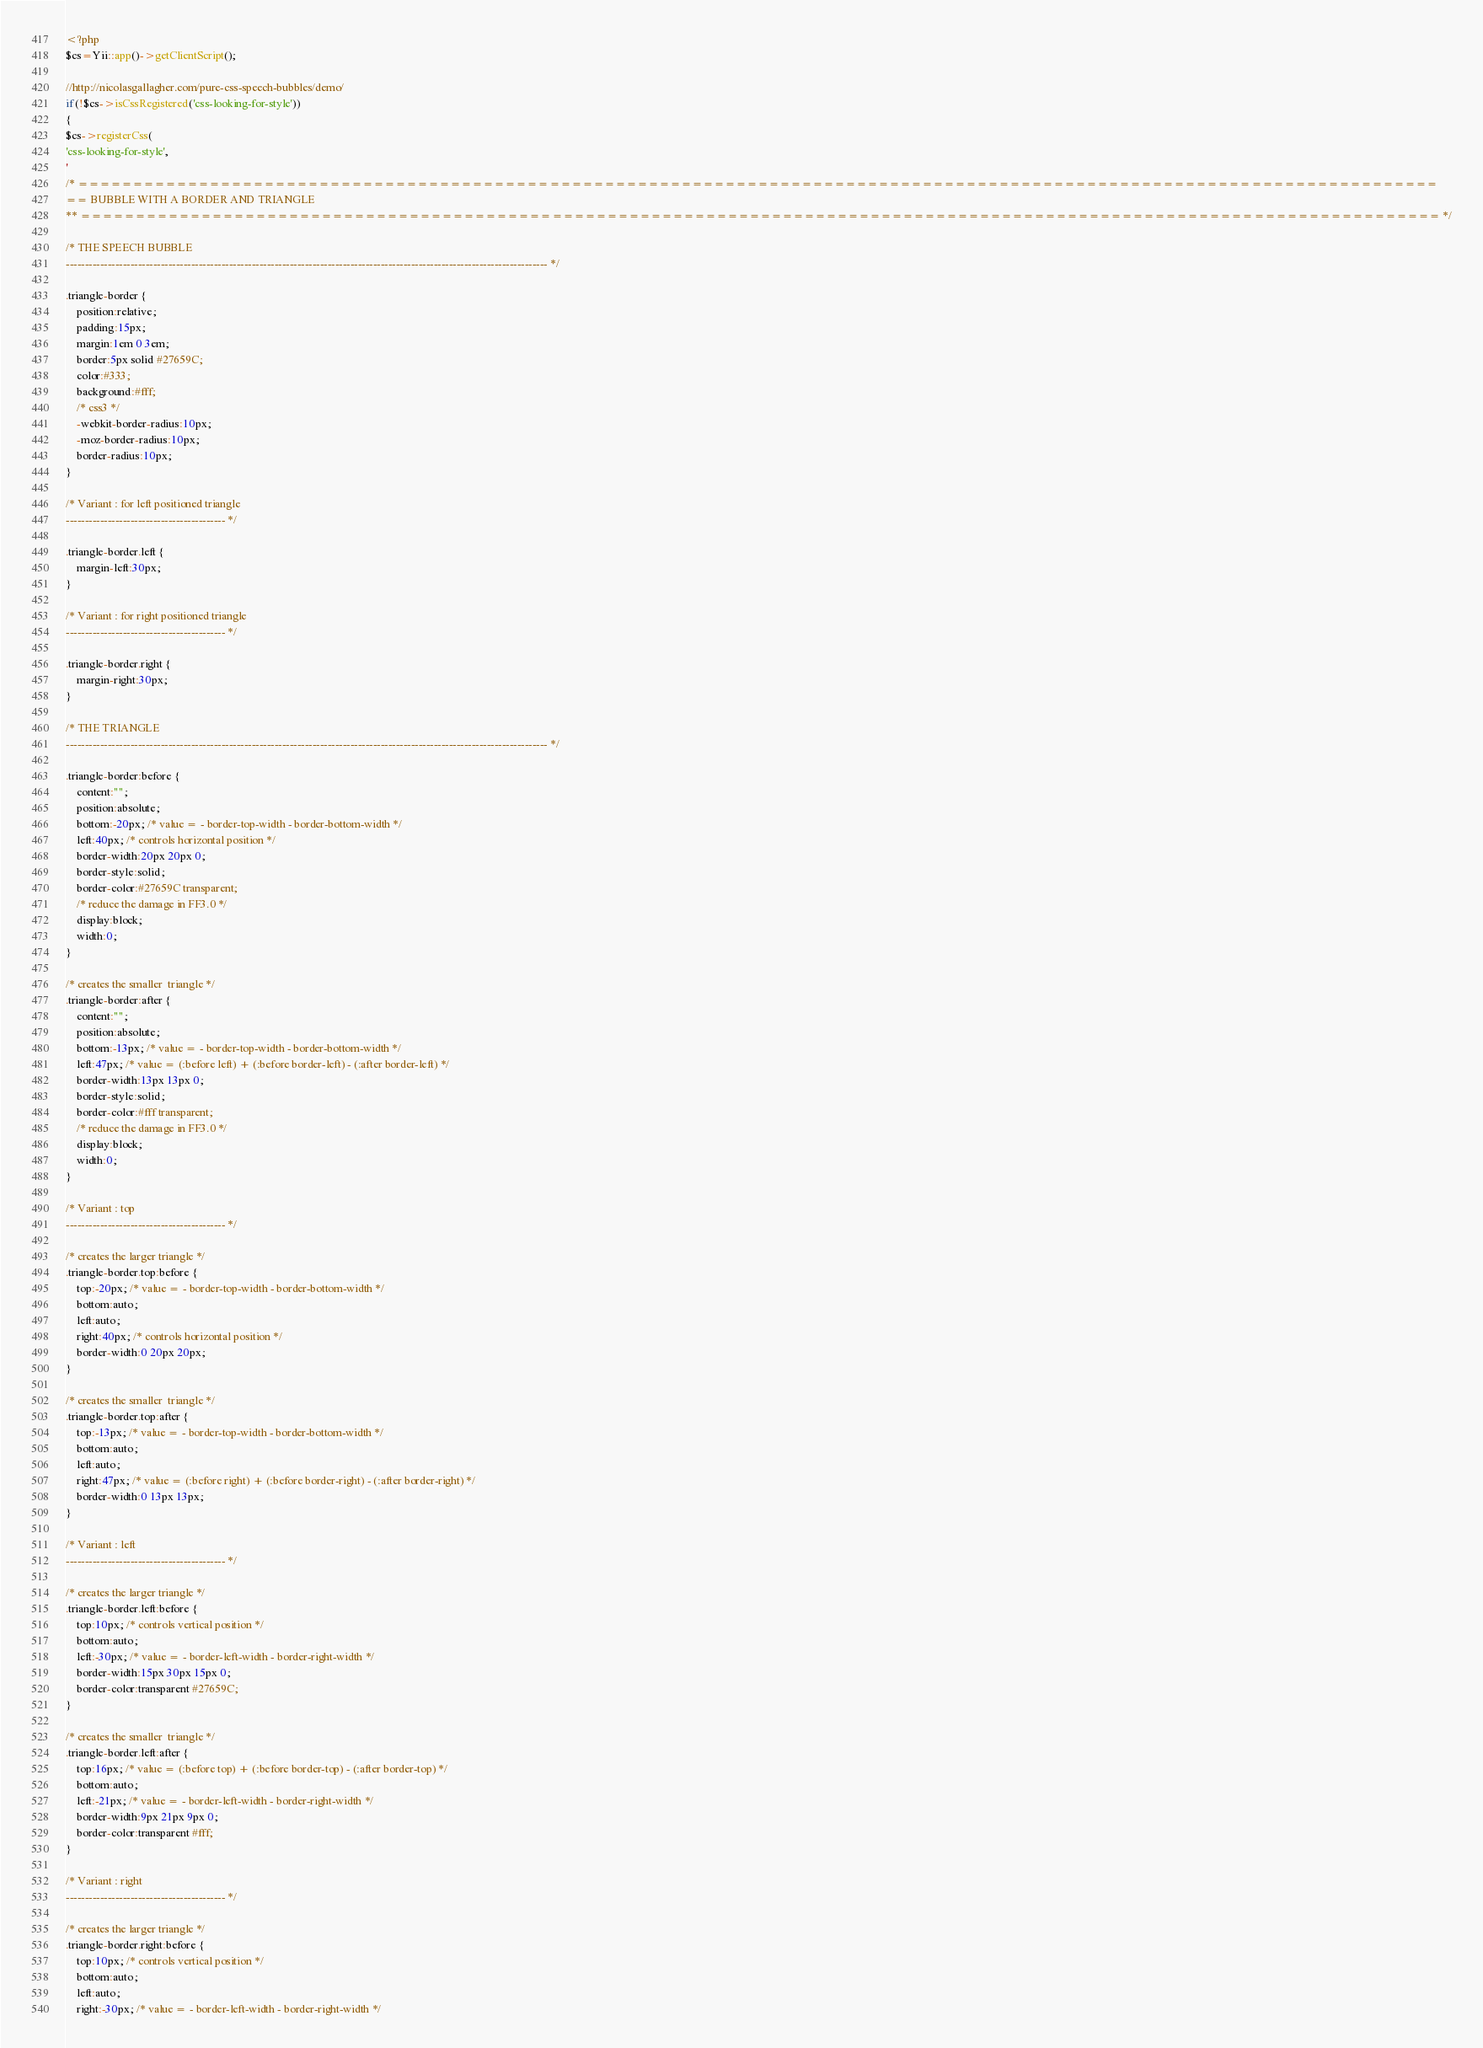Convert code to text. <code><loc_0><loc_0><loc_500><loc_500><_PHP_><?php
$cs=Yii::app()->getClientScript();

//http://nicolasgallagher.com/pure-css-speech-bubbles/demo/
if(!$cs->isCssRegistered('css-looking-for-style'))
{
$cs->registerCss(
'css-looking-for-style',
'
/* ============================================================================================================================
== BUBBLE WITH A BORDER AND TRIANGLE
** ============================================================================================================================ */

/* THE SPEECH BUBBLE
------------------------------------------------------------------------------------------------------------------------------- */

.triangle-border {
	position:relative;
	padding:15px;
	margin:1em 0 3em;
	border:5px solid #27659C;
	color:#333;
	background:#fff;
	/* css3 */
	-webkit-border-radius:10px;
	-moz-border-radius:10px;
	border-radius:10px;
}

/* Variant : for left positioned triangle
------------------------------------------ */

.triangle-border.left {
	margin-left:30px;
}

/* Variant : for right positioned triangle
------------------------------------------ */

.triangle-border.right {
	margin-right:30px;
}

/* THE TRIANGLE
------------------------------------------------------------------------------------------------------------------------------- */

.triangle-border:before {
	content:"";
	position:absolute;
	bottom:-20px; /* value = - border-top-width - border-bottom-width */
	left:40px; /* controls horizontal position */
    border-width:20px 20px 0;
	border-style:solid;
    border-color:#27659C transparent;
    /* reduce the damage in FF3.0 */
    display:block; 
    width:0;
}

/* creates the smaller  triangle */
.triangle-border:after {
	content:"";
	position:absolute;
	bottom:-13px; /* value = - border-top-width - border-bottom-width */
	left:47px; /* value = (:before left) + (:before border-left) - (:after border-left) */
	border-width:13px 13px 0;
	border-style:solid;
	border-color:#fff transparent;
    /* reduce the damage in FF3.0 */
    display:block; 
    width:0;
}

/* Variant : top
------------------------------------------ */

/* creates the larger triangle */
.triangle-border.top:before {
	top:-20px; /* value = - border-top-width - border-bottom-width */
	bottom:auto;
	left:auto;
	right:40px; /* controls horizontal position */
    border-width:0 20px 20px;
}

/* creates the smaller  triangle */
.triangle-border.top:after {
	top:-13px; /* value = - border-top-width - border-bottom-width */
	bottom:auto;
	left:auto;
	right:47px; /* value = (:before right) + (:before border-right) - (:after border-right) */
    border-width:0 13px 13px;
}

/* Variant : left
------------------------------------------ */

/* creates the larger triangle */
.triangle-border.left:before {
	top:10px; /* controls vertical position */
	bottom:auto;
	left:-30px; /* value = - border-left-width - border-right-width */
	border-width:15px 30px 15px 0;
	border-color:transparent #27659C;
}

/* creates the smaller  triangle */
.triangle-border.left:after {
	top:16px; /* value = (:before top) + (:before border-top) - (:after border-top) */
	bottom:auto;
	left:-21px; /* value = - border-left-width - border-right-width */
	border-width:9px 21px 9px 0;
	border-color:transparent #fff;
}

/* Variant : right
------------------------------------------ */

/* creates the larger triangle */
.triangle-border.right:before {
	top:10px; /* controls vertical position */
	bottom:auto;
    left:auto;
	right:-30px; /* value = - border-left-width - border-right-width */</code> 